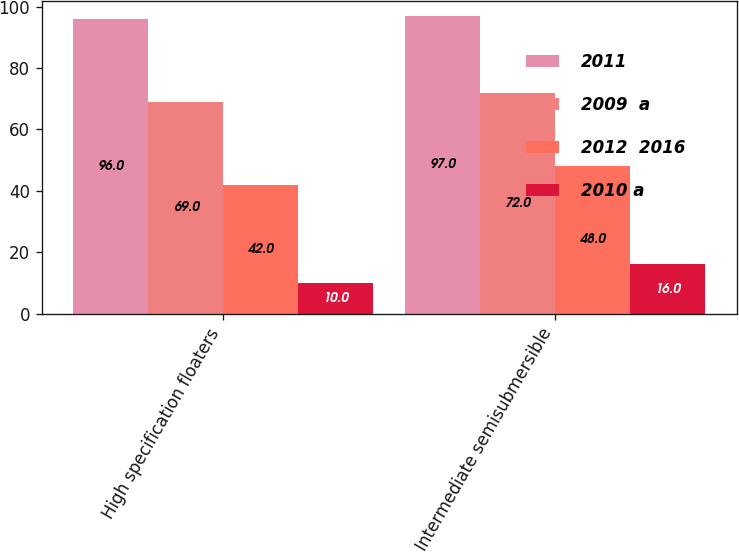Convert chart. <chart><loc_0><loc_0><loc_500><loc_500><stacked_bar_chart><ecel><fcel>High specification floaters<fcel>Intermediate semisubmersible<nl><fcel>2011<fcel>96<fcel>97<nl><fcel>2009  a<fcel>69<fcel>72<nl><fcel>2012  2016<fcel>42<fcel>48<nl><fcel>2010 a<fcel>10<fcel>16<nl></chart> 